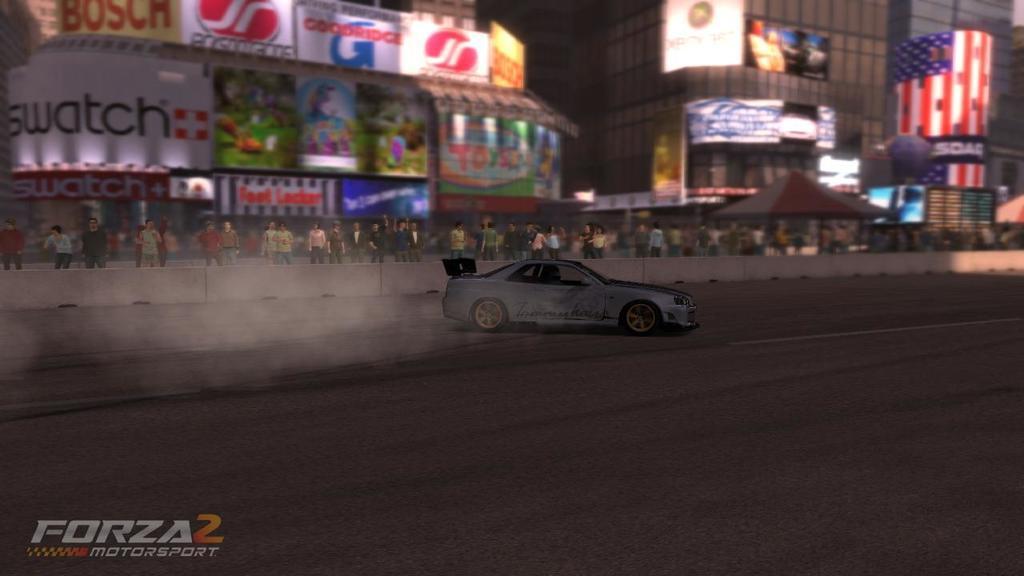In one or two sentences, can you explain what this image depicts? This is an animated image. We can see a person is riding car on the road. In the background there are buildings, poles, hoardings, few persons are standing at the fence, tents and objects. On the left side at the bottom corner there is a text on the image. 